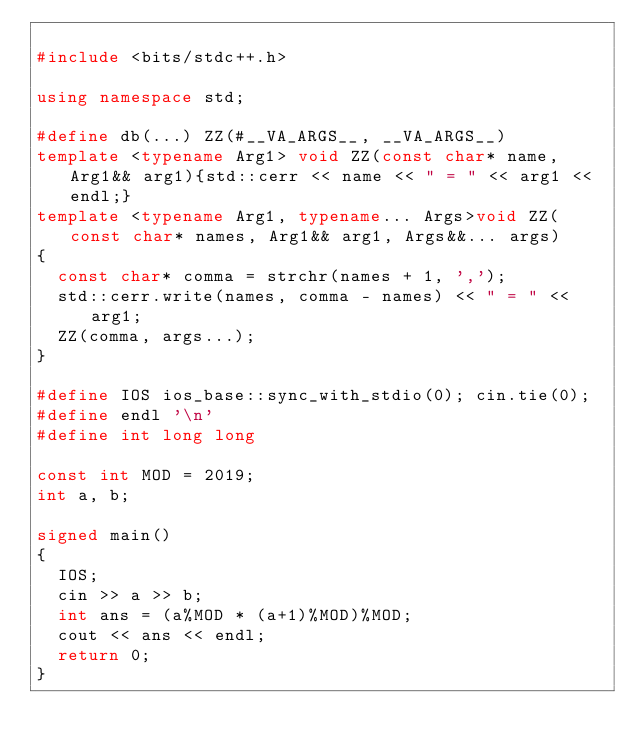<code> <loc_0><loc_0><loc_500><loc_500><_C++_>
#include <bits/stdc++.h>

using namespace std;

#define db(...) ZZ(#__VA_ARGS__, __VA_ARGS__)
template <typename Arg1> void ZZ(const char* name, Arg1&& arg1){std::cerr << name << " = " << arg1 << endl;}
template <typename Arg1, typename... Args>void ZZ(const char* names, Arg1&& arg1, Args&&... args)
{
	const char* comma = strchr(names + 1, ',');
	std::cerr.write(names, comma - names) << " = " << arg1;
	ZZ(comma, args...);
}

#define IOS ios_base::sync_with_stdio(0); cin.tie(0);
#define endl '\n'
#define int long long

const int MOD = 2019;
int a, b;

signed main()
{
	IOS;
	cin >> a >> b;
	int ans = (a%MOD * (a+1)%MOD)%MOD;
	cout << ans << endl;
	return 0;
}

</code> 